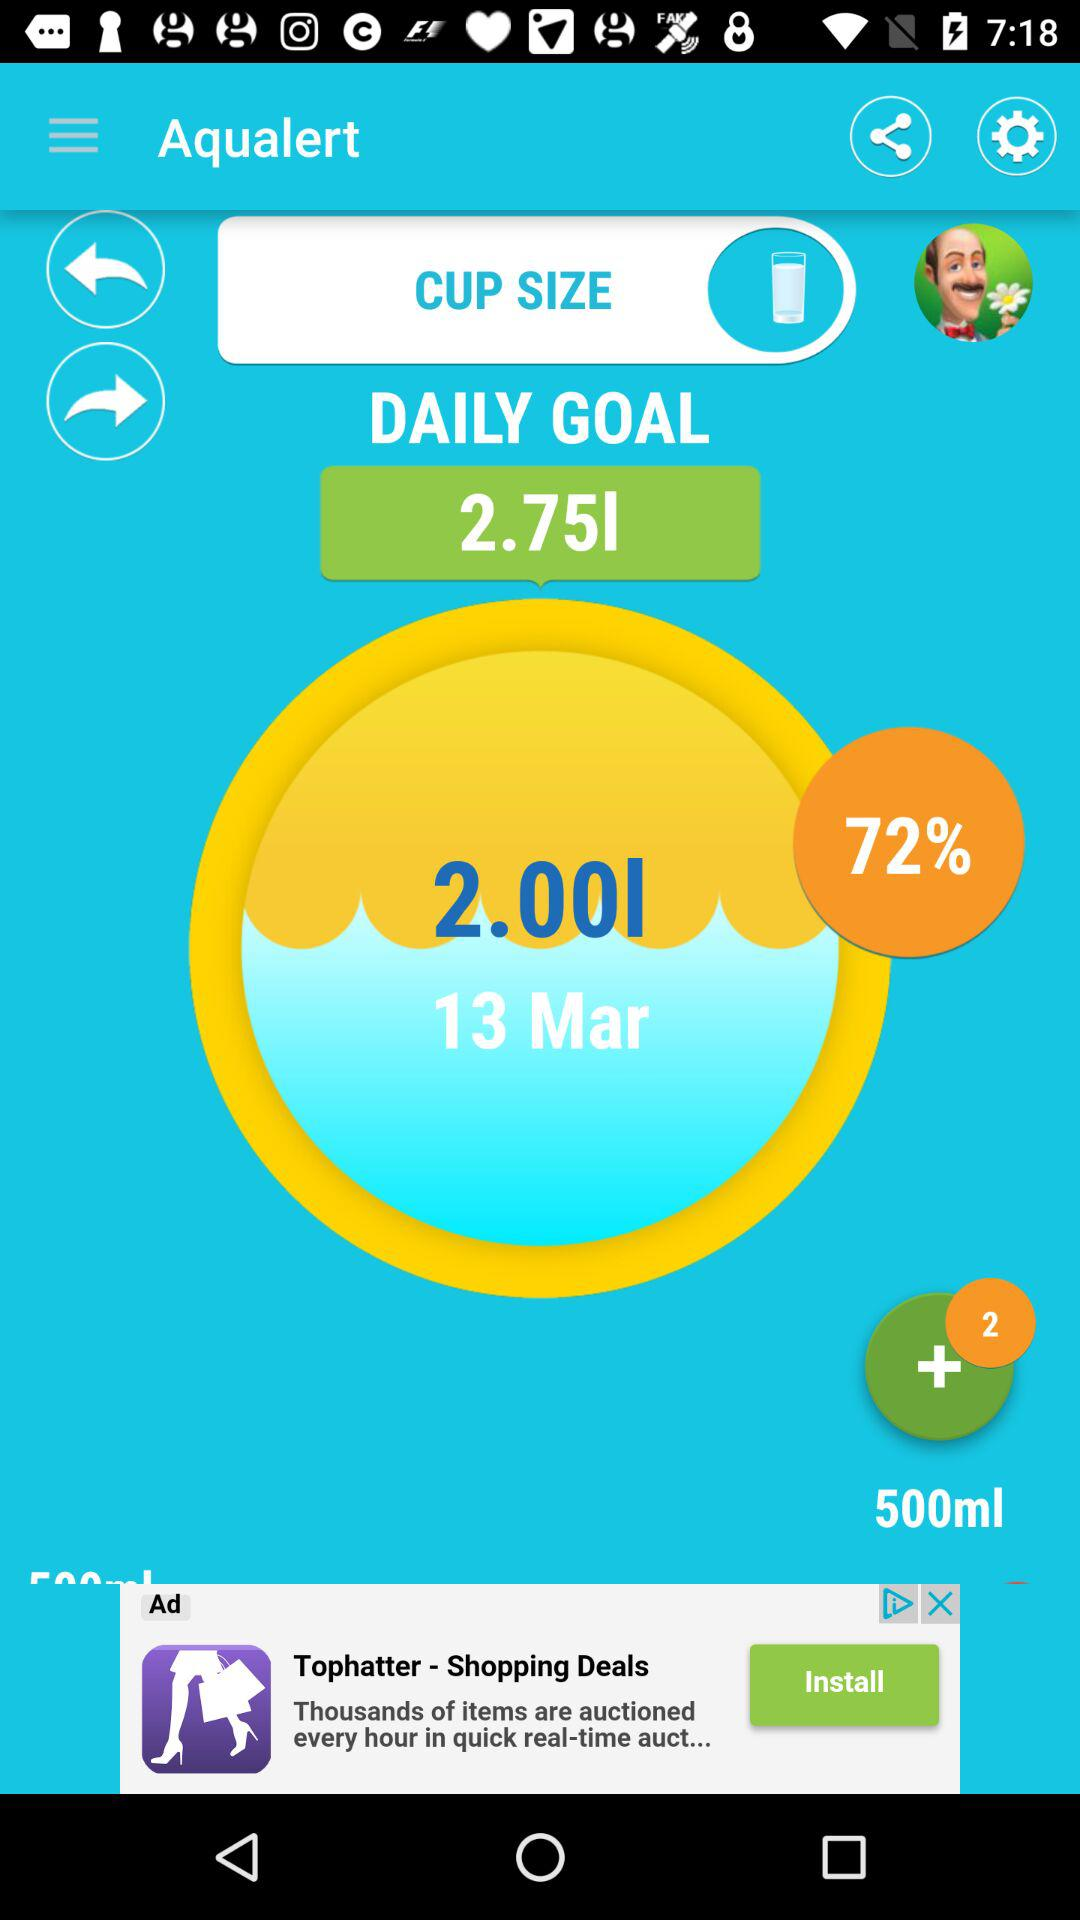What is the daily goal? The daily goal is 2.75 l. 